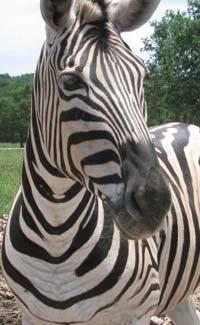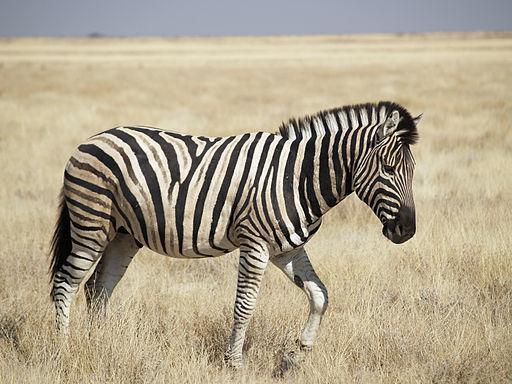The first image is the image on the left, the second image is the image on the right. Evaluate the accuracy of this statement regarding the images: "The left image shows a standing zebra colt with upright head next to a standing adult zebra with its head lowered to graze.". Is it true? Answer yes or no. No. The first image is the image on the left, the second image is the image on the right. Evaluate the accuracy of this statement regarding the images: "Two zebras are standing in the grass in at least one of the images.". Is it true? Answer yes or no. No. 